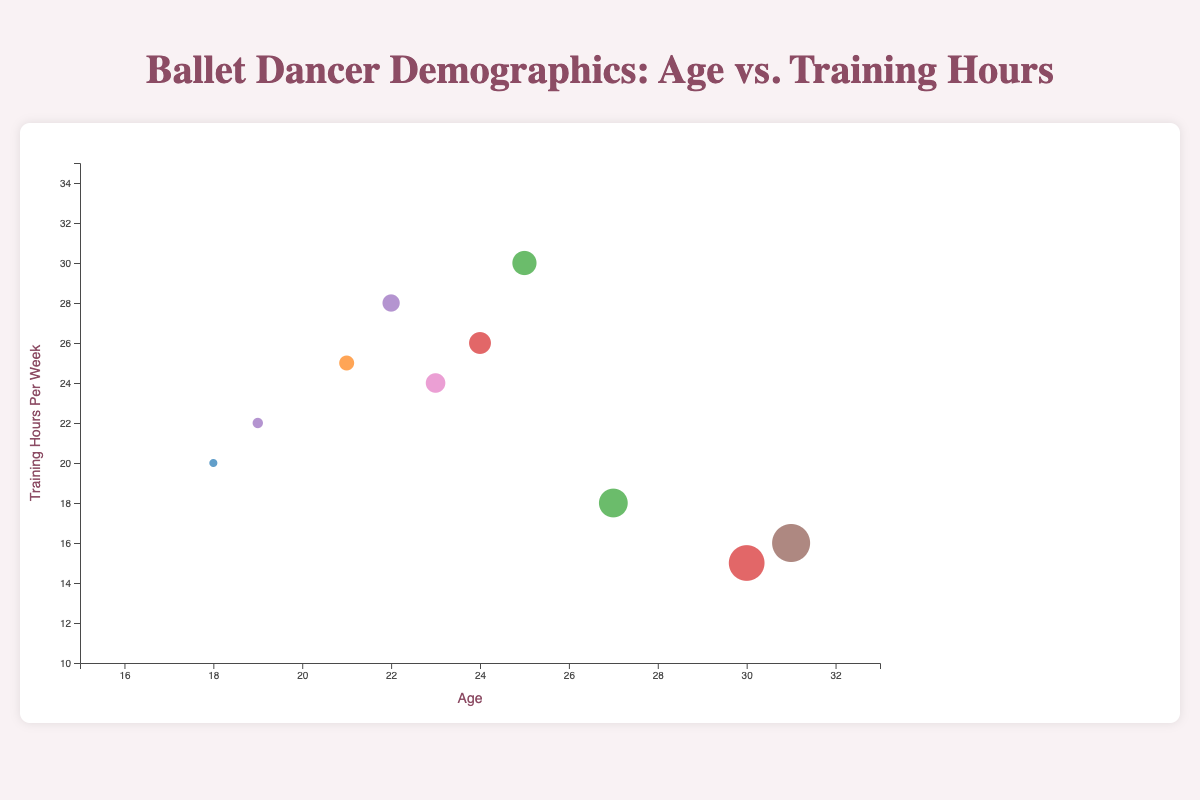What is the title of the chart? The title is displayed at the top of the chart, describing its subject.
Answer: Ballet Dancer Demographics: Age vs. Training Hours How many dancers are represented in the chart? Count the number of bubbles displayed in the chart. Each bubble represents one dancer.
Answer: 10 Which dancer has the highest training hours per week? Identify the bubble that is positioned the highest on the y-axis, which represents training hours per week.
Answer: Rudolf Nureyev How many dancers are from the Royal Ballet? Observe the legend or tooltip and count the bubbles that correspond to the Royal Ballet.
Answer: 2 What is the age and training hours per week of the youngest dancer? Look for the smallest value on the x-axis (Age) and identify the associated training hours per week from the tooltip or y-axis.
Answer: Age: 18, Training Hours: 20 What is the average age of dancers training over 25 hours per week? Identify dancers with more than 25 training hours per week (by y-axis or tooltip), sum their ages, and divide by the number of these dancers. Dancers: Vaslav Nijinsky (21), Rudolf Nureyev (25), Sergei Polunin (24). (21+25+24) / 3 = 23.33
Answer: 23.33 How do training hours per week generally trend with age among the dancers? Observe the overall positioning of bubbles from left to right (age) and up to down (training hours).
Answer: Generally increasing Which company has the most diverse age group of dancers? Compare the spread of ages (x-axis) for each colored group (company).
Answer: American Ballet Theatre Do older dancers tend to train fewer hours than younger dancers in the dataset? Observe the trend of bubbles as age increases (left to right) and their corresponding y-axis position (training hours).
Answer: Yes, generally Between Mikhail Baryshnikov and Misty Copeland, who trains more hours per week? Check the y-axis value or tooltip for each dancer to compare their training hours per week.
Answer: Mikhail Baryshnikov 